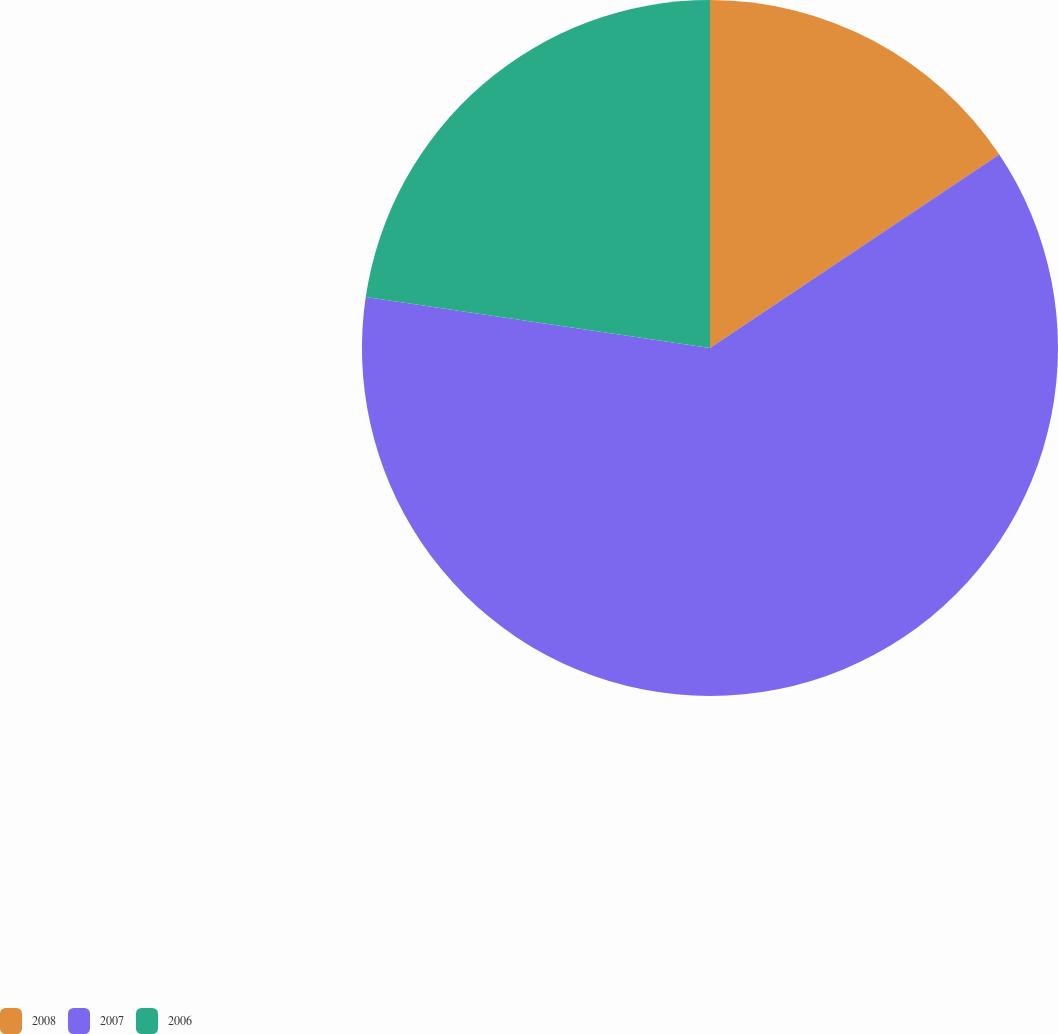Convert chart to OTSL. <chart><loc_0><loc_0><loc_500><loc_500><pie_chart><fcel>2008<fcel>2007<fcel>2006<nl><fcel>15.62%<fcel>61.72%<fcel>22.66%<nl></chart> 